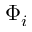<formula> <loc_0><loc_0><loc_500><loc_500>\Phi _ { i }</formula> 